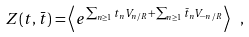Convert formula to latex. <formula><loc_0><loc_0><loc_500><loc_500>Z ( t , \bar { t } ) = \left < e ^ { \sum _ { n \geq 1 } t _ { n } V _ { n / R } + \sum _ { n \geq 1 } \bar { t } _ { n } V _ { - n / R } } \right > \ ,</formula> 